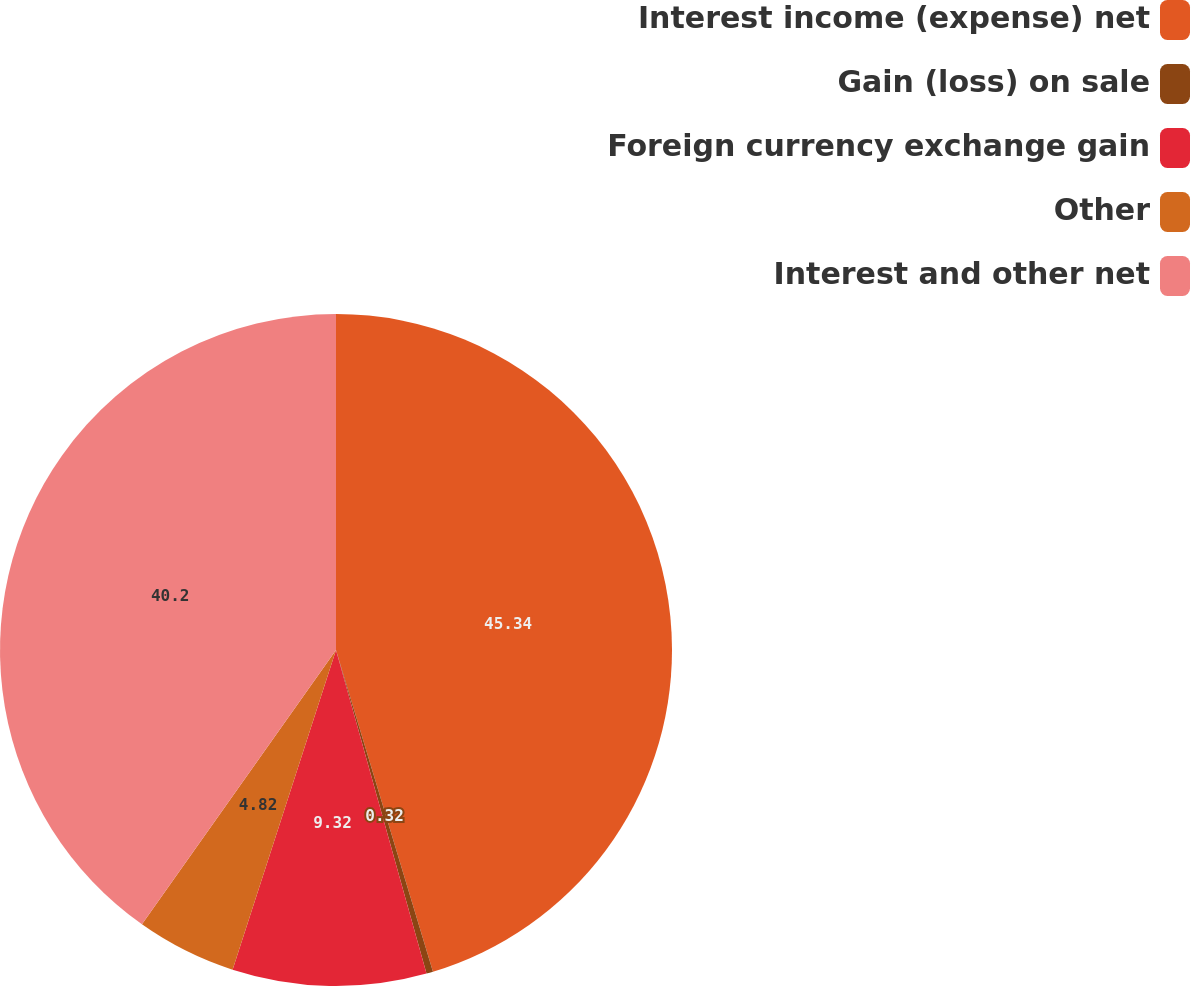Convert chart. <chart><loc_0><loc_0><loc_500><loc_500><pie_chart><fcel>Interest income (expense) net<fcel>Gain (loss) on sale<fcel>Foreign currency exchange gain<fcel>Other<fcel>Interest and other net<nl><fcel>45.34%<fcel>0.32%<fcel>9.32%<fcel>4.82%<fcel>40.2%<nl></chart> 